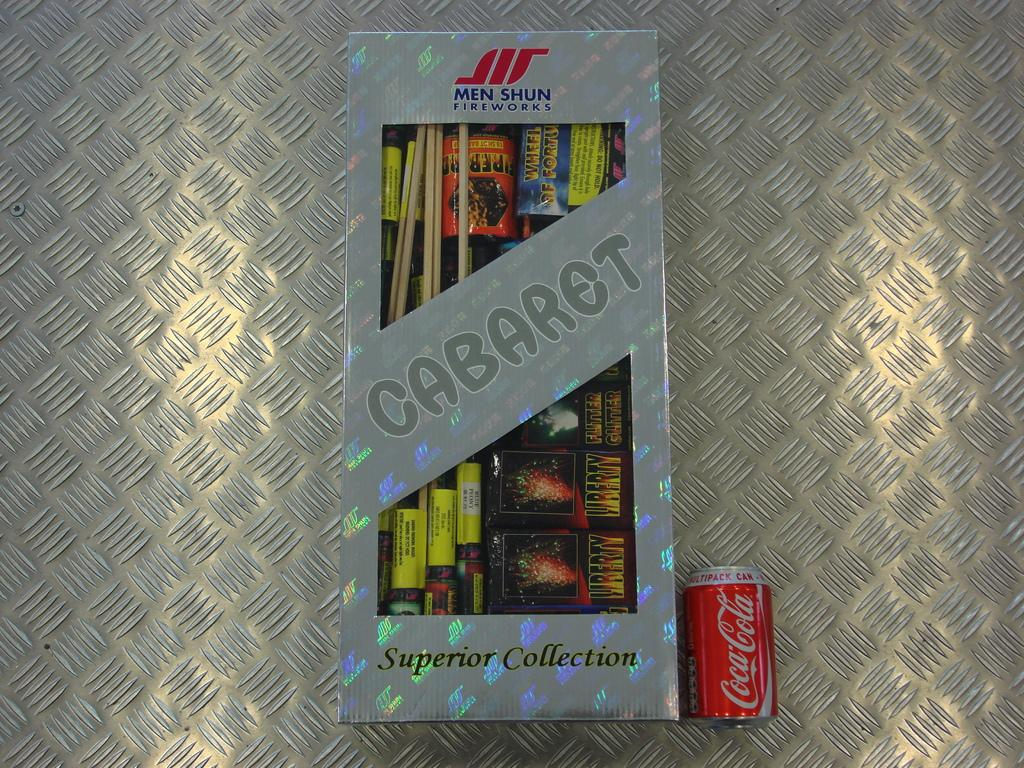<image>
Relay a brief, clear account of the picture shown. A box of brand new fireworks laying next to a coca cola can. 